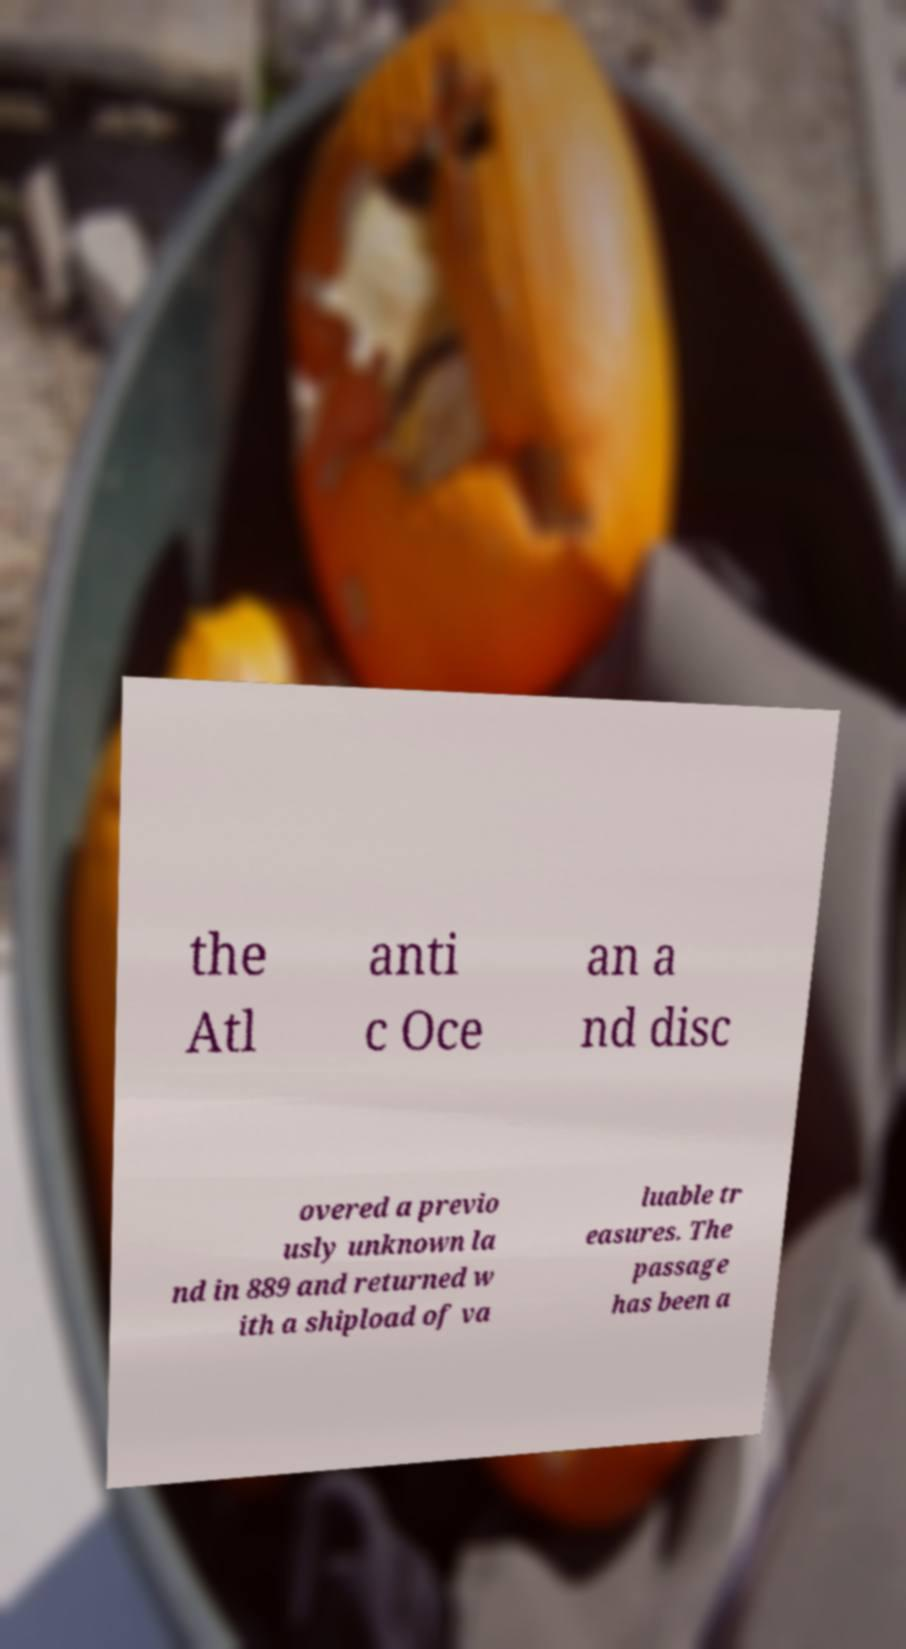What messages or text are displayed in this image? I need them in a readable, typed format. the Atl anti c Oce an a nd disc overed a previo usly unknown la nd in 889 and returned w ith a shipload of va luable tr easures. The passage has been a 